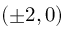<formula> <loc_0><loc_0><loc_500><loc_500>( \pm 2 , 0 )</formula> 